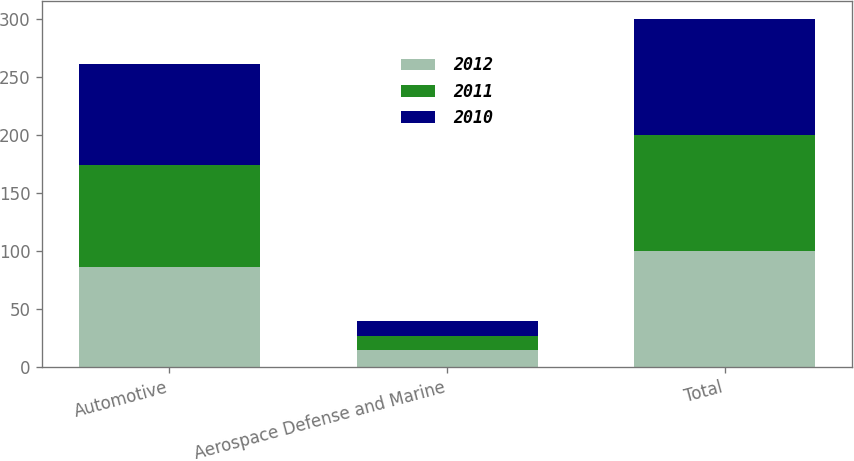<chart> <loc_0><loc_0><loc_500><loc_500><stacked_bar_chart><ecel><fcel>Automotive<fcel>Aerospace Defense and Marine<fcel>Total<nl><fcel>2012<fcel>86<fcel>14<fcel>100<nl><fcel>2011<fcel>88<fcel>12<fcel>100<nl><fcel>2010<fcel>87<fcel>13<fcel>100<nl></chart> 